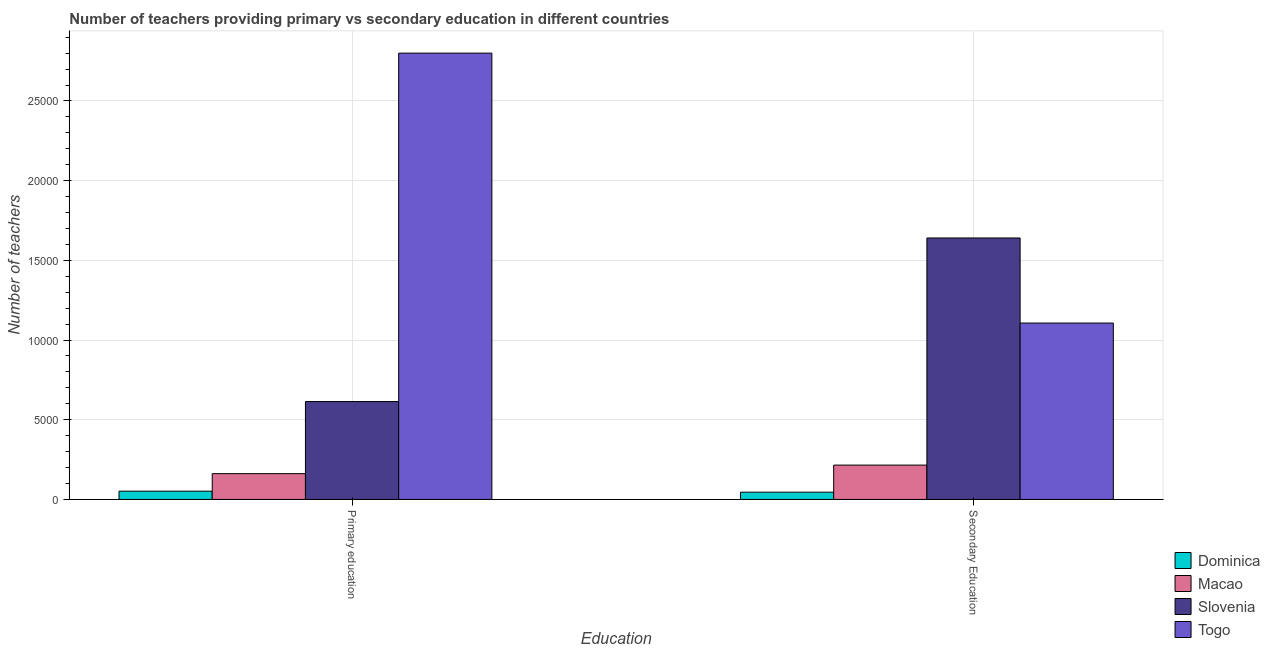How many different coloured bars are there?
Make the answer very short. 4. How many groups of bars are there?
Provide a succinct answer. 2. Are the number of bars on each tick of the X-axis equal?
Your answer should be very brief. Yes. What is the label of the 1st group of bars from the left?
Provide a succinct answer. Primary education. What is the number of primary teachers in Dominica?
Your response must be concise. 517. Across all countries, what is the maximum number of secondary teachers?
Your response must be concise. 1.64e+04. Across all countries, what is the minimum number of secondary teachers?
Keep it short and to the point. 455. In which country was the number of primary teachers maximum?
Give a very brief answer. Togo. In which country was the number of primary teachers minimum?
Offer a very short reply. Dominica. What is the total number of secondary teachers in the graph?
Keep it short and to the point. 3.01e+04. What is the difference between the number of secondary teachers in Dominica and that in Slovenia?
Offer a very short reply. -1.60e+04. What is the difference between the number of secondary teachers in Slovenia and the number of primary teachers in Togo?
Make the answer very short. -1.16e+04. What is the average number of secondary teachers per country?
Your response must be concise. 7520.25. What is the difference between the number of primary teachers and number of secondary teachers in Macao?
Your answer should be very brief. -537. What is the ratio of the number of secondary teachers in Macao to that in Togo?
Your answer should be very brief. 0.19. Is the number of secondary teachers in Slovenia less than that in Dominica?
Provide a short and direct response. No. What does the 1st bar from the left in Secondary Education represents?
Ensure brevity in your answer.  Dominica. What does the 3rd bar from the right in Secondary Education represents?
Provide a succinct answer. Macao. What is the difference between two consecutive major ticks on the Y-axis?
Ensure brevity in your answer.  5000. Where does the legend appear in the graph?
Your answer should be compact. Bottom right. How many legend labels are there?
Give a very brief answer. 4. What is the title of the graph?
Offer a very short reply. Number of teachers providing primary vs secondary education in different countries. What is the label or title of the X-axis?
Your answer should be compact. Education. What is the label or title of the Y-axis?
Offer a terse response. Number of teachers. What is the Number of teachers in Dominica in Primary education?
Your answer should be very brief. 517. What is the Number of teachers of Macao in Primary education?
Offer a very short reply. 1617. What is the Number of teachers in Slovenia in Primary education?
Ensure brevity in your answer.  6141. What is the Number of teachers in Togo in Primary education?
Offer a very short reply. 2.80e+04. What is the Number of teachers of Dominica in Secondary Education?
Your answer should be compact. 455. What is the Number of teachers in Macao in Secondary Education?
Give a very brief answer. 2154. What is the Number of teachers in Slovenia in Secondary Education?
Provide a short and direct response. 1.64e+04. What is the Number of teachers of Togo in Secondary Education?
Provide a short and direct response. 1.11e+04. Across all Education, what is the maximum Number of teachers in Dominica?
Your answer should be very brief. 517. Across all Education, what is the maximum Number of teachers in Macao?
Keep it short and to the point. 2154. Across all Education, what is the maximum Number of teachers in Slovenia?
Provide a succinct answer. 1.64e+04. Across all Education, what is the maximum Number of teachers in Togo?
Keep it short and to the point. 2.80e+04. Across all Education, what is the minimum Number of teachers of Dominica?
Keep it short and to the point. 455. Across all Education, what is the minimum Number of teachers of Macao?
Your answer should be very brief. 1617. Across all Education, what is the minimum Number of teachers in Slovenia?
Offer a very short reply. 6141. Across all Education, what is the minimum Number of teachers in Togo?
Your answer should be compact. 1.11e+04. What is the total Number of teachers in Dominica in the graph?
Give a very brief answer. 972. What is the total Number of teachers of Macao in the graph?
Your response must be concise. 3771. What is the total Number of teachers of Slovenia in the graph?
Make the answer very short. 2.25e+04. What is the total Number of teachers in Togo in the graph?
Ensure brevity in your answer.  3.91e+04. What is the difference between the Number of teachers in Dominica in Primary education and that in Secondary Education?
Your response must be concise. 62. What is the difference between the Number of teachers in Macao in Primary education and that in Secondary Education?
Provide a short and direct response. -537. What is the difference between the Number of teachers of Slovenia in Primary education and that in Secondary Education?
Offer a terse response. -1.03e+04. What is the difference between the Number of teachers of Togo in Primary education and that in Secondary Education?
Your answer should be very brief. 1.69e+04. What is the difference between the Number of teachers of Dominica in Primary education and the Number of teachers of Macao in Secondary Education?
Your answer should be very brief. -1637. What is the difference between the Number of teachers of Dominica in Primary education and the Number of teachers of Slovenia in Secondary Education?
Ensure brevity in your answer.  -1.59e+04. What is the difference between the Number of teachers of Dominica in Primary education and the Number of teachers of Togo in Secondary Education?
Give a very brief answer. -1.06e+04. What is the difference between the Number of teachers in Macao in Primary education and the Number of teachers in Slovenia in Secondary Education?
Offer a very short reply. -1.48e+04. What is the difference between the Number of teachers in Macao in Primary education and the Number of teachers in Togo in Secondary Education?
Your response must be concise. -9450. What is the difference between the Number of teachers of Slovenia in Primary education and the Number of teachers of Togo in Secondary Education?
Your response must be concise. -4926. What is the average Number of teachers in Dominica per Education?
Keep it short and to the point. 486. What is the average Number of teachers of Macao per Education?
Provide a short and direct response. 1885.5. What is the average Number of teachers of Slovenia per Education?
Give a very brief answer. 1.13e+04. What is the average Number of teachers in Togo per Education?
Your answer should be very brief. 1.95e+04. What is the difference between the Number of teachers of Dominica and Number of teachers of Macao in Primary education?
Give a very brief answer. -1100. What is the difference between the Number of teachers of Dominica and Number of teachers of Slovenia in Primary education?
Provide a succinct answer. -5624. What is the difference between the Number of teachers in Dominica and Number of teachers in Togo in Primary education?
Provide a short and direct response. -2.75e+04. What is the difference between the Number of teachers of Macao and Number of teachers of Slovenia in Primary education?
Offer a terse response. -4524. What is the difference between the Number of teachers in Macao and Number of teachers in Togo in Primary education?
Offer a very short reply. -2.64e+04. What is the difference between the Number of teachers of Slovenia and Number of teachers of Togo in Primary education?
Offer a terse response. -2.19e+04. What is the difference between the Number of teachers of Dominica and Number of teachers of Macao in Secondary Education?
Your answer should be compact. -1699. What is the difference between the Number of teachers of Dominica and Number of teachers of Slovenia in Secondary Education?
Make the answer very short. -1.60e+04. What is the difference between the Number of teachers in Dominica and Number of teachers in Togo in Secondary Education?
Provide a succinct answer. -1.06e+04. What is the difference between the Number of teachers in Macao and Number of teachers in Slovenia in Secondary Education?
Your response must be concise. -1.43e+04. What is the difference between the Number of teachers of Macao and Number of teachers of Togo in Secondary Education?
Make the answer very short. -8913. What is the difference between the Number of teachers of Slovenia and Number of teachers of Togo in Secondary Education?
Offer a very short reply. 5338. What is the ratio of the Number of teachers in Dominica in Primary education to that in Secondary Education?
Provide a short and direct response. 1.14. What is the ratio of the Number of teachers in Macao in Primary education to that in Secondary Education?
Provide a succinct answer. 0.75. What is the ratio of the Number of teachers in Slovenia in Primary education to that in Secondary Education?
Make the answer very short. 0.37. What is the ratio of the Number of teachers of Togo in Primary education to that in Secondary Education?
Your answer should be compact. 2.53. What is the difference between the highest and the second highest Number of teachers in Macao?
Your answer should be compact. 537. What is the difference between the highest and the second highest Number of teachers of Slovenia?
Your response must be concise. 1.03e+04. What is the difference between the highest and the second highest Number of teachers of Togo?
Provide a short and direct response. 1.69e+04. What is the difference between the highest and the lowest Number of teachers in Dominica?
Give a very brief answer. 62. What is the difference between the highest and the lowest Number of teachers of Macao?
Your answer should be compact. 537. What is the difference between the highest and the lowest Number of teachers in Slovenia?
Offer a terse response. 1.03e+04. What is the difference between the highest and the lowest Number of teachers in Togo?
Your answer should be compact. 1.69e+04. 